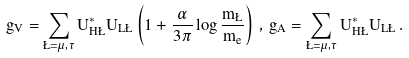<formula> <loc_0><loc_0><loc_500><loc_500>g _ { V } = \sum _ { \L = \mu , \tau } U _ { H \L } ^ { * } U _ { L \L } \left ( 1 + { \frac { \alpha } { 3 \pi } } \log { \frac { m _ { \L } } { m _ { e } } } \right ) \, , \, g _ { A } = \sum _ { \L = \mu , \tau } U _ { H \L } ^ { * } U _ { L \L } \, .</formula> 